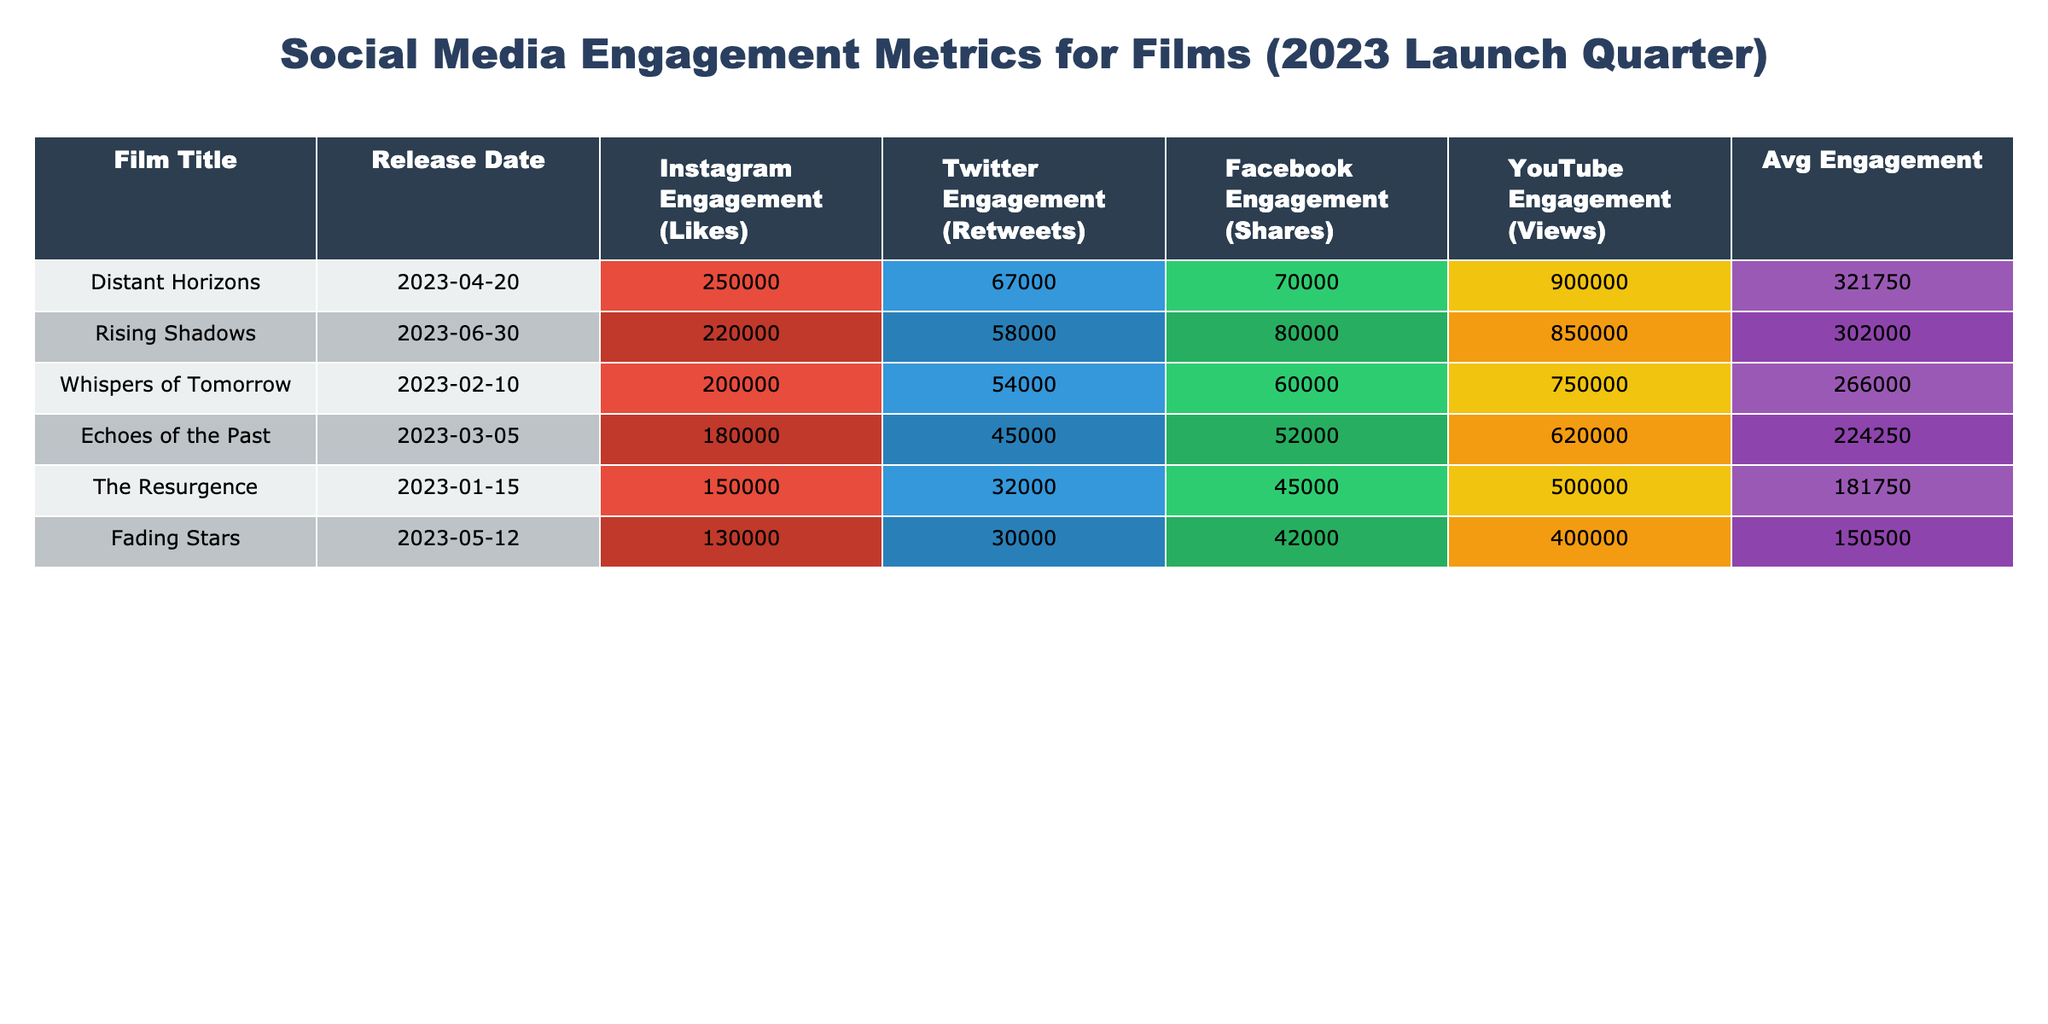What film had the highest Instagram engagement? By looking at the Instagram Engagement column, we can see that the film "Distant Horizons" has the highest number of likes at 250,000.
Answer: Distant Horizons What is the total Twitter engagement for films released in March and April? Checking the Twitter Engagement for "Echoes of the Past" (45,000) and "Distant Horizons" (67,000), we sum these two values: 45,000 + 67,000 = 112,000.
Answer: 112000 Which film had the lowest number of Facebook shares? Looking at the Facebook Engagement column, "Fading Stars" has the lowest shares at 42,000 when compared with the rest.
Answer: Fading Stars Was "Fading Stars" the film with the least overall average engagement? First, we find the average engagement for "Fading Stars": (130,000 + 30,000 + 42,000 + 400,000) / 4 = 150,000. Comparing this with the averages of other films, it turns out that "Fading Stars" has the lowest average engagement score among the films listed.
Answer: Yes What is the average YouTube engagement for films with more than 200,000 Instagram likes? The films with more than 200,000 Instagram likes are "Distant Horizons" (900,000 views), "Rising Shadows" (850,000 views), and "Whispers of Tomorrow" (750,000 views). Summing these gives 900,000 + 850,000 + 750,000 = 2,500,000, and dividing by 3 gives an average of 833,333.33.
Answer: 833333.33 What is the average engagement across all platforms for "Whispers of Tomorrow"? To calculate this, add the engagement metrics: 200,000 (Instagram) + 54,000 (Twitter) + 60,000 (Facebook) + 750,000 (YouTube) = 1,064,000. Now, divide by 4 (number of platforms) to get an average of 266,000.
Answer: 266000 Was Twitter engagement for "Rising Shadows" greater than 60,000? From the table, "Rising Shadows" has 58,000 Twitter engagements, meaning it is less than 60,000.
Answer: No Which two films had a combined total Facebook share count of more than 120,000? Looking at the Facebook Engagements for "Distant Horizons" (70,000) and "Rising Shadows" (80,000), which when added together gives: 70,000 + 80,000 = 150,000, which is more than 120,000.
Answer: Yes 